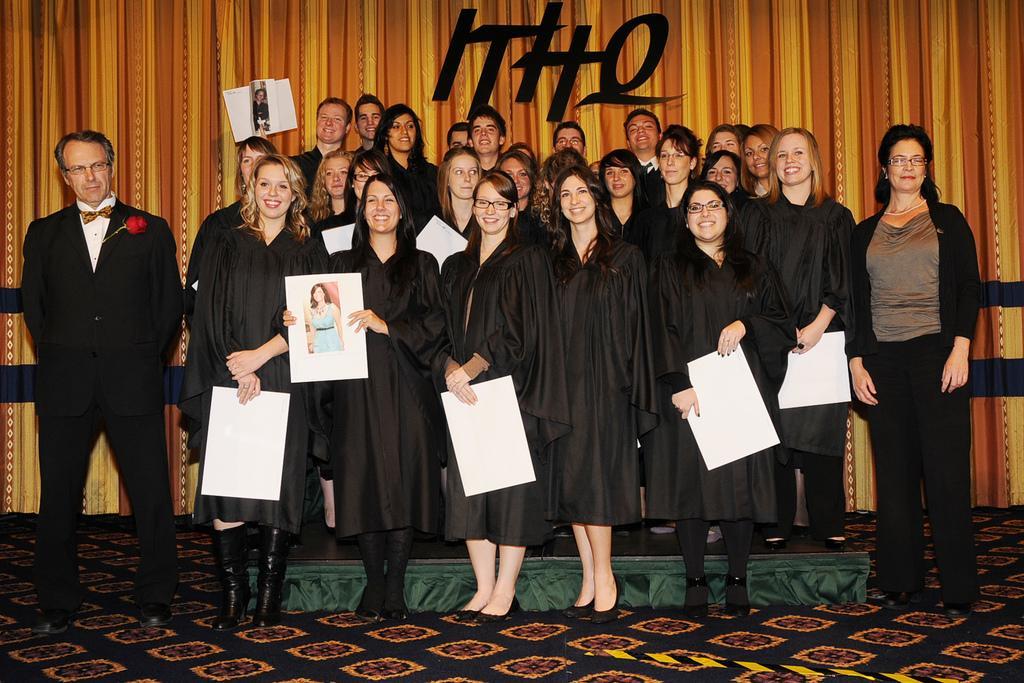Could you give a brief overview of what you see in this image? In this image there are group of persons standing, the persons are holding objects, at the background of the image there is a curtain truncated, there is text on the curtain, there is a paper on the curtain. 